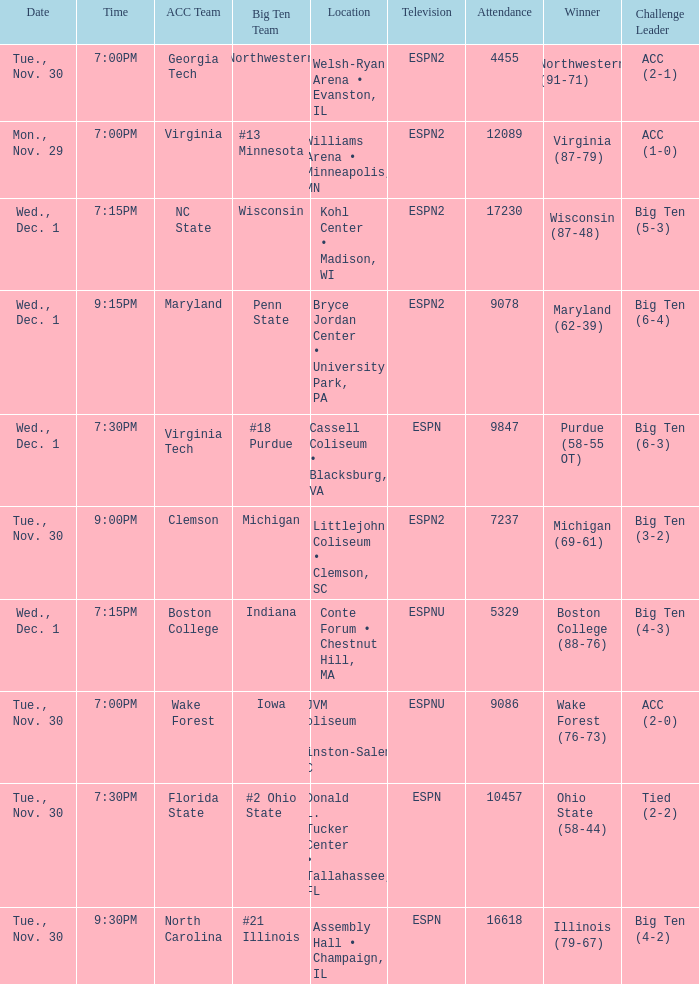What was the time of the games that took place at the cassell coliseum • blacksburg, va? 7:30PM. 